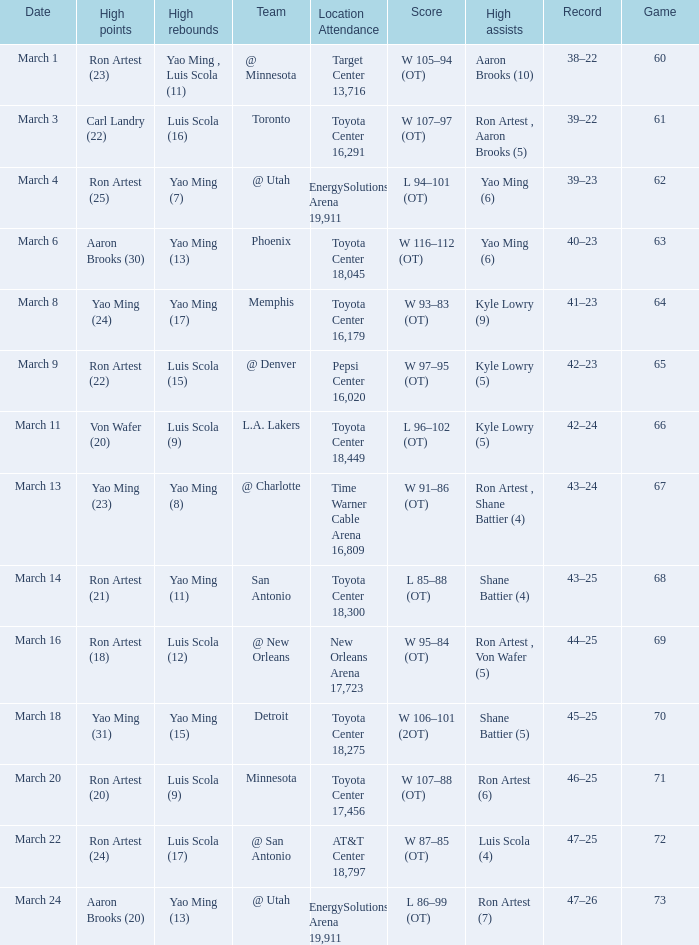On what date did the Rockets play Memphis? March 8. 